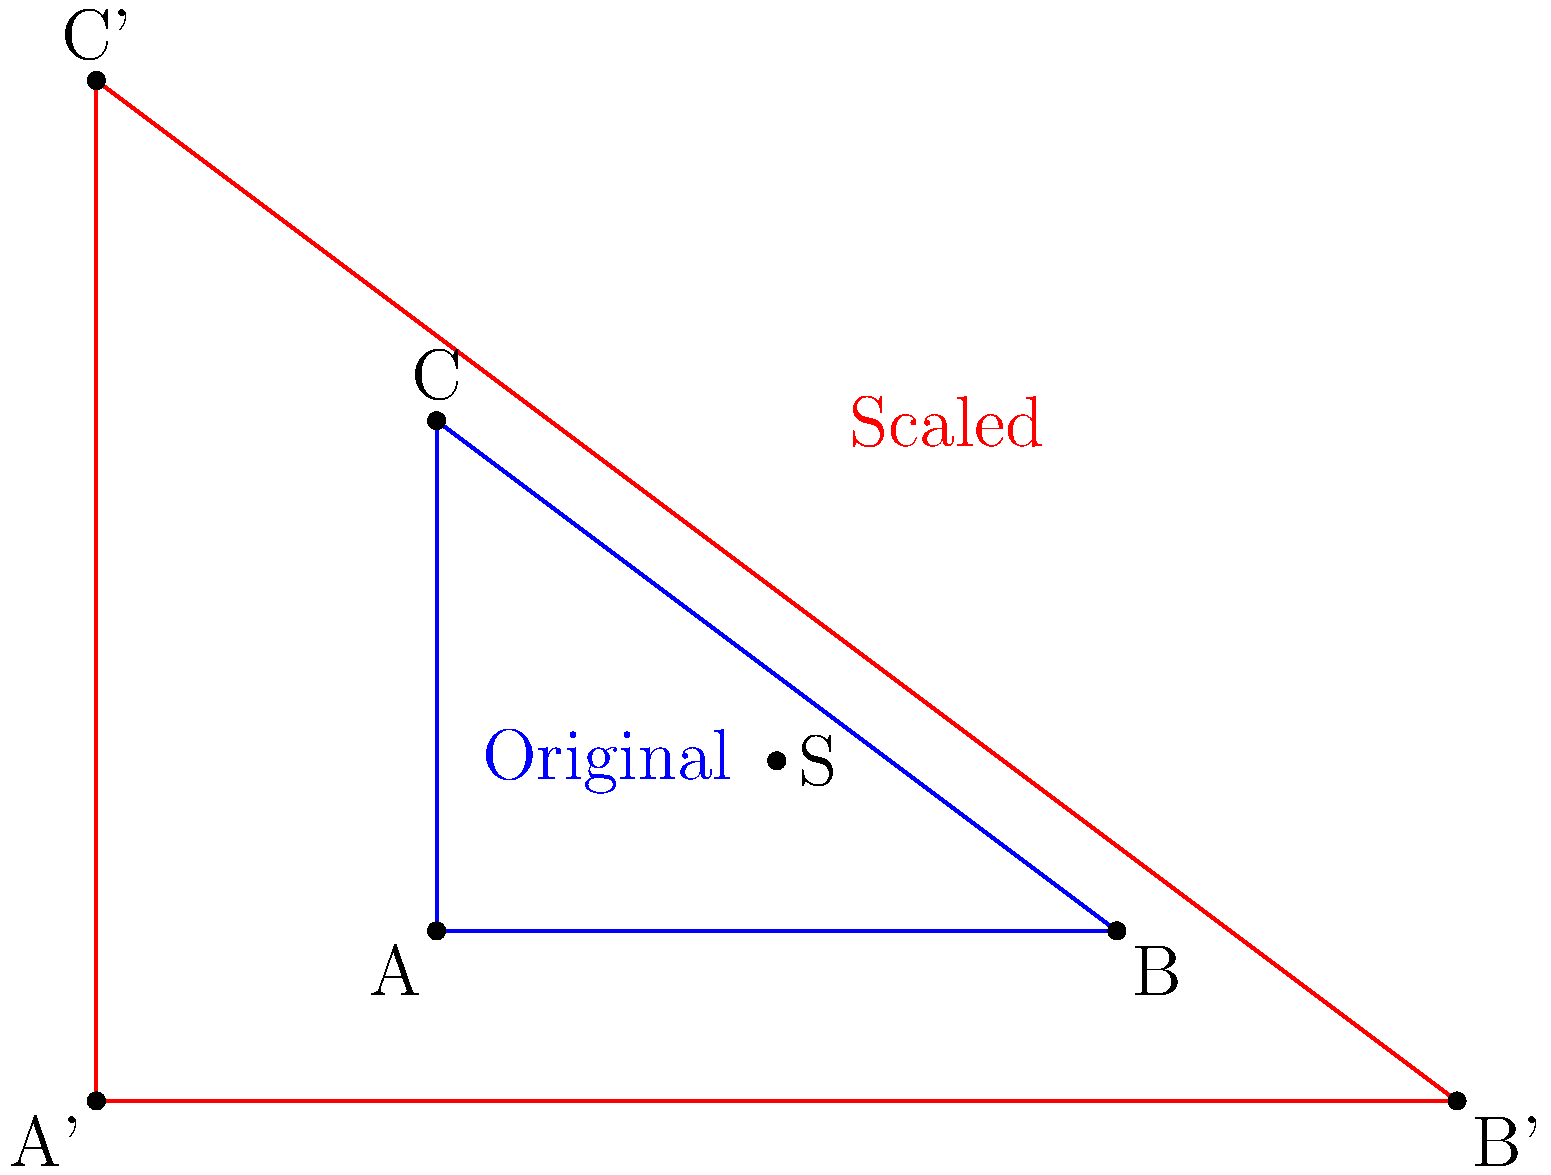In the figure above, triangle ABC is scaled by a factor of 2 from point S(2,1). If the original area of triangle ABC is 6 square units, what is the area of the scaled triangle A'B'C'? Disregard any budget constraints and focus solely on the geometric transformation. To solve this problem, we'll follow these steps:

1) First, recall that when a figure is scaled by a factor of k from any point, its area is multiplied by $k^2$.

2) In this case, the scaling factor is 2, so the area will be multiplied by $2^2 = 4$.

3) We're given that the original area of triangle ABC is 6 square units.

4) Therefore, the area of the scaled triangle A'B'C' will be:

   $\text{New Area} = \text{Original Area} \times (\text{Scaling Factor})^2$
   $\text{New Area} = 6 \times 2^2 = 6 \times 4 = 24$

5) It's important to note that this result is independent of the point from which we scale (point S in this case). The scaling point only affects the position of the new triangle, not its size.
Answer: 24 square units 